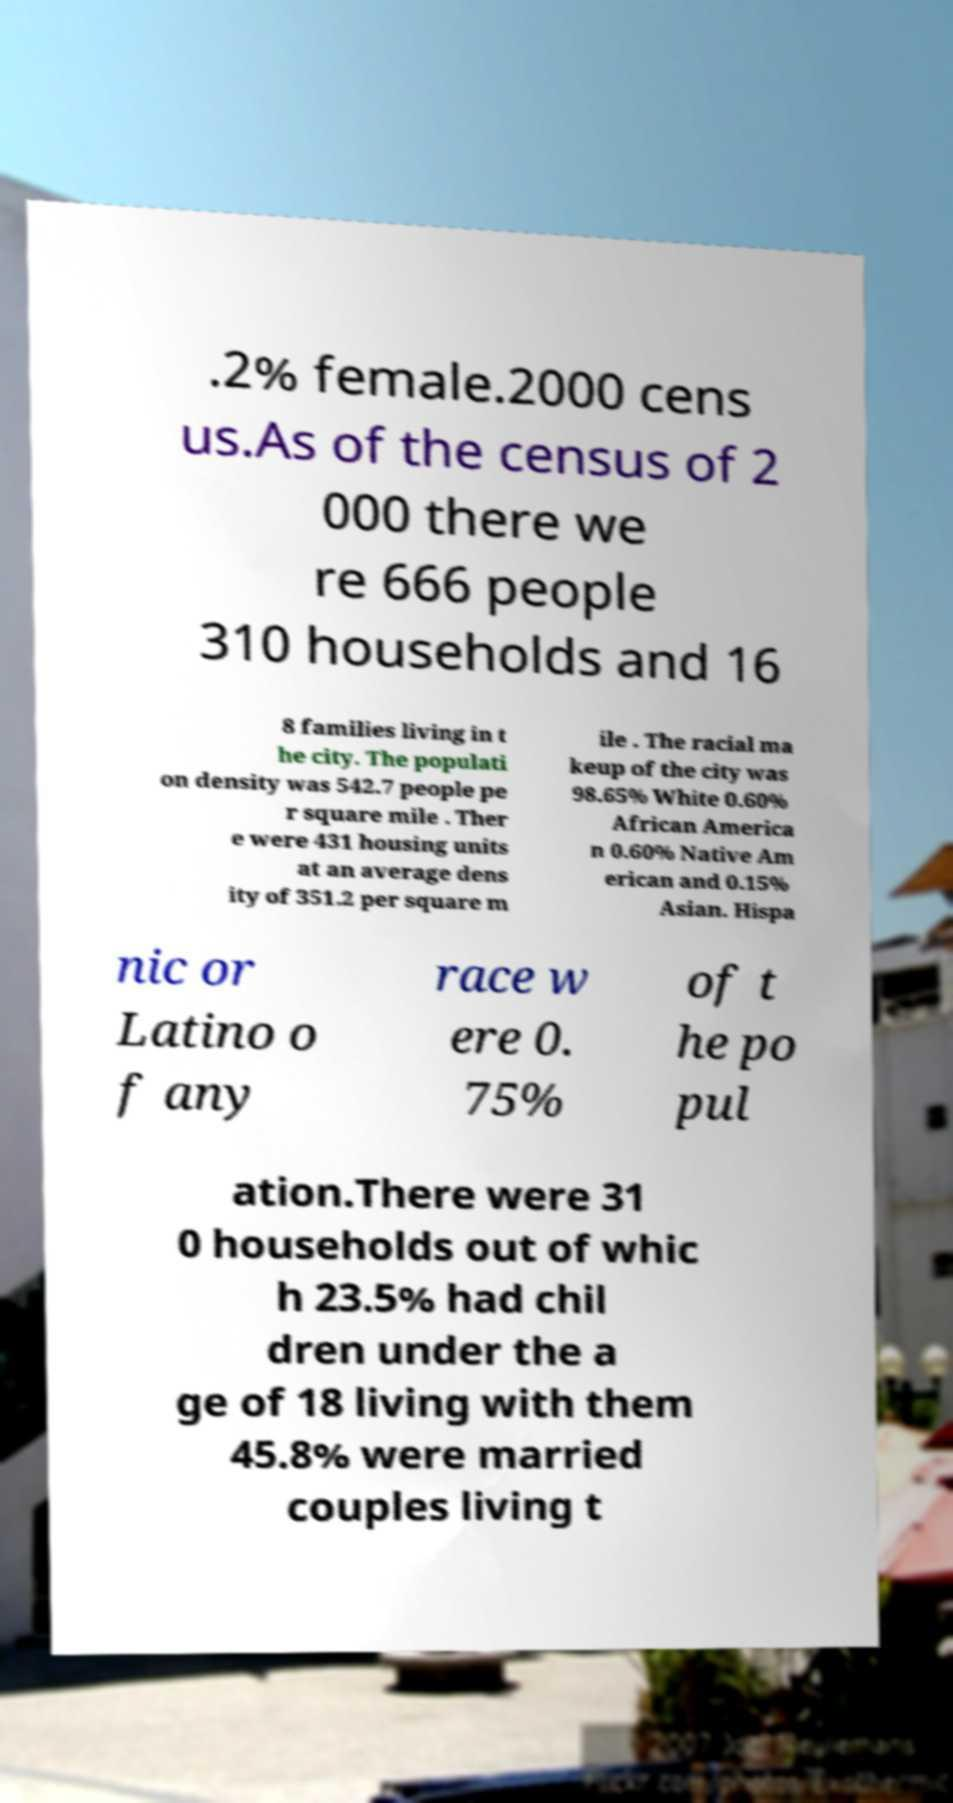Please read and relay the text visible in this image. What does it say? .2% female.2000 cens us.As of the census of 2 000 there we re 666 people 310 households and 16 8 families living in t he city. The populati on density was 542.7 people pe r square mile . Ther e were 431 housing units at an average dens ity of 351.2 per square m ile . The racial ma keup of the city was 98.65% White 0.60% African America n 0.60% Native Am erican and 0.15% Asian. Hispa nic or Latino o f any race w ere 0. 75% of t he po pul ation.There were 31 0 households out of whic h 23.5% had chil dren under the a ge of 18 living with them 45.8% were married couples living t 